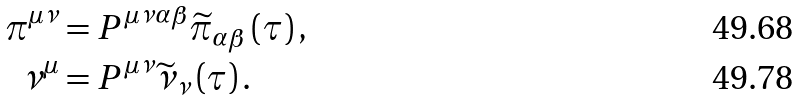<formula> <loc_0><loc_0><loc_500><loc_500>\pi ^ { \mu \nu } & = P ^ { \mu \nu \alpha \beta } \widetilde { \pi } _ { \alpha \beta } \left ( \tau \right ) , \\ \nu ^ { \mu } & = P ^ { \mu \nu } \widetilde { \nu } _ { \nu } \left ( \tau \right ) .</formula> 